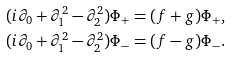Convert formula to latex. <formula><loc_0><loc_0><loc_500><loc_500>& ( i \partial _ { 0 } + \partial _ { 1 } ^ { 2 } - \partial _ { 2 } ^ { 2 } ) \Phi _ { + } = ( f + g ) \Phi _ { + } , \\ & ( i \partial _ { 0 } + \partial _ { 1 } ^ { 2 } - \partial _ { 2 } ^ { 2 } ) \Phi _ { - } = ( f - g ) \Phi _ { - } .</formula> 